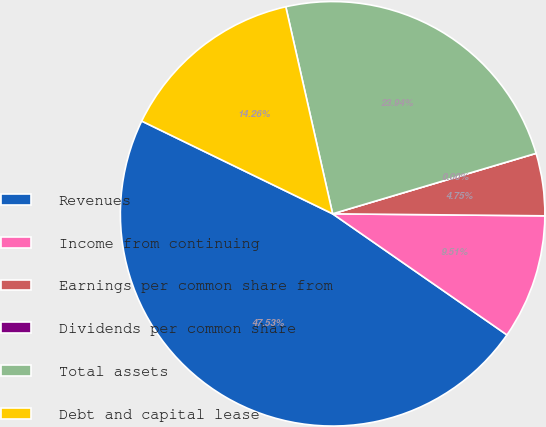<chart> <loc_0><loc_0><loc_500><loc_500><pie_chart><fcel>Revenues<fcel>Income from continuing<fcel>Earnings per common share from<fcel>Dividends per common share<fcel>Total assets<fcel>Debt and capital lease<nl><fcel>47.53%<fcel>9.51%<fcel>4.75%<fcel>0.0%<fcel>23.94%<fcel>14.26%<nl></chart> 